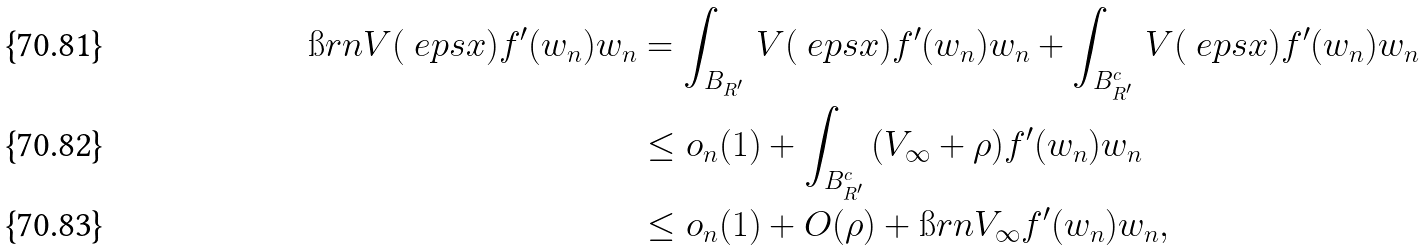<formula> <loc_0><loc_0><loc_500><loc_500>\i r n V ( \ e p s x ) f ^ { \prime } ( w _ { n } ) w _ { n } & = \int _ { B _ { R ^ { \prime } } } \, V ( \ e p s x ) f ^ { \prime } ( w _ { n } ) w _ { n } + \int _ { B _ { R ^ { \prime } } ^ { c } } \, V ( \ e p s x ) f ^ { \prime } ( w _ { n } ) w _ { n } \\ & \leq o _ { n } ( 1 ) + \int _ { B _ { R ^ { \prime } } ^ { c } } \, ( V _ { \infty } + \rho ) f ^ { \prime } ( w _ { n } ) w _ { n } \\ & \leq o _ { n } ( 1 ) + O ( \rho ) + \i r n V _ { \infty } f ^ { \prime } ( w _ { n } ) w _ { n } ,</formula> 